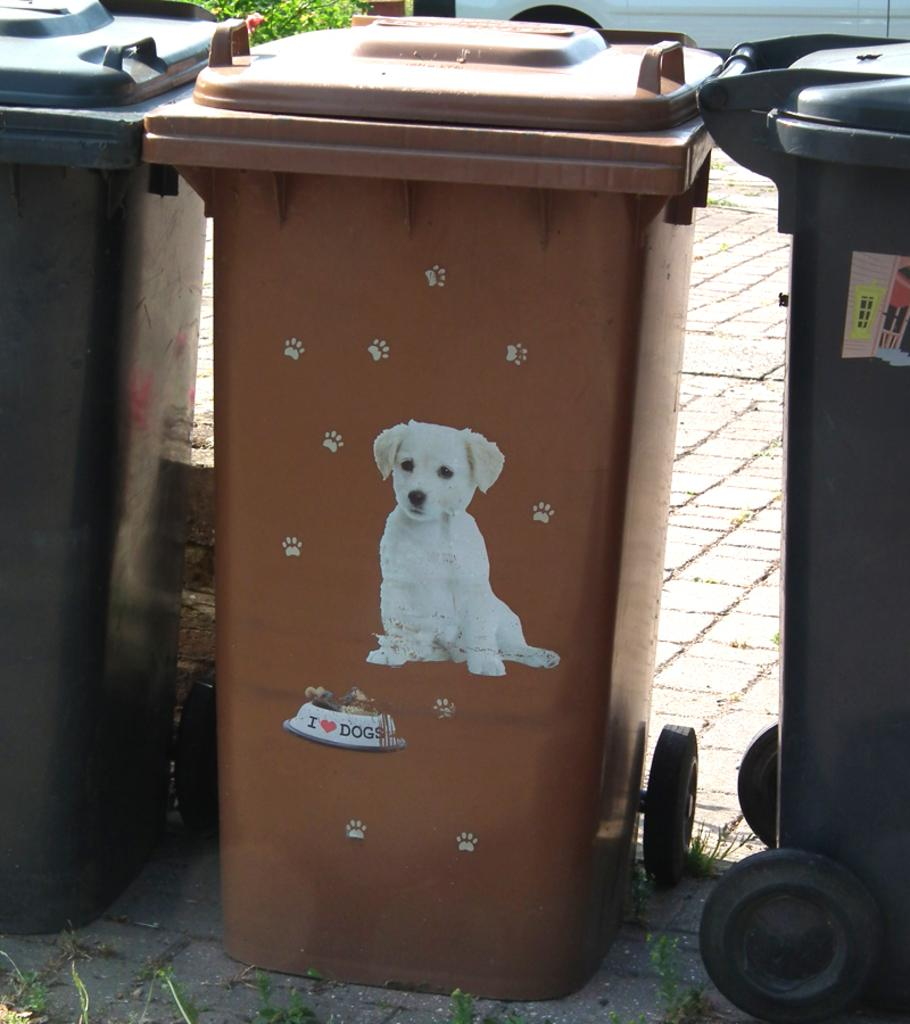<image>
Render a clear and concise summary of the photo. Brown garbage can which says I Love Dogs on it. 